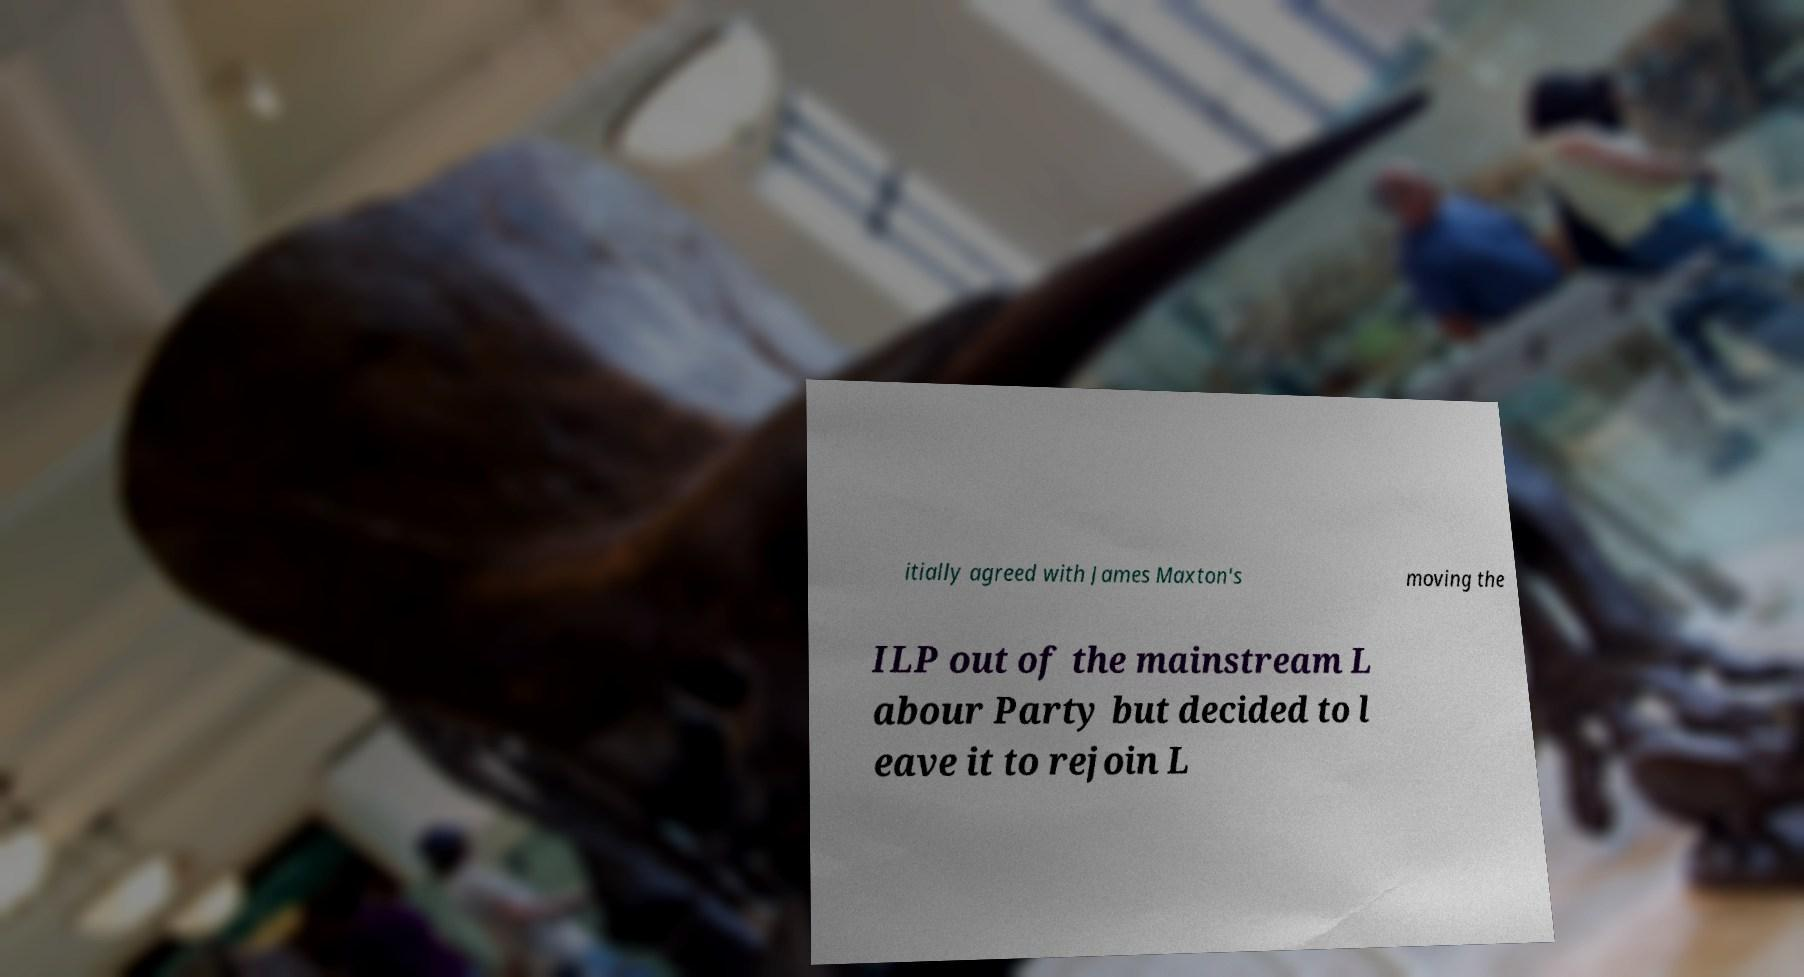Could you assist in decoding the text presented in this image and type it out clearly? itially agreed with James Maxton's moving the ILP out of the mainstream L abour Party but decided to l eave it to rejoin L 